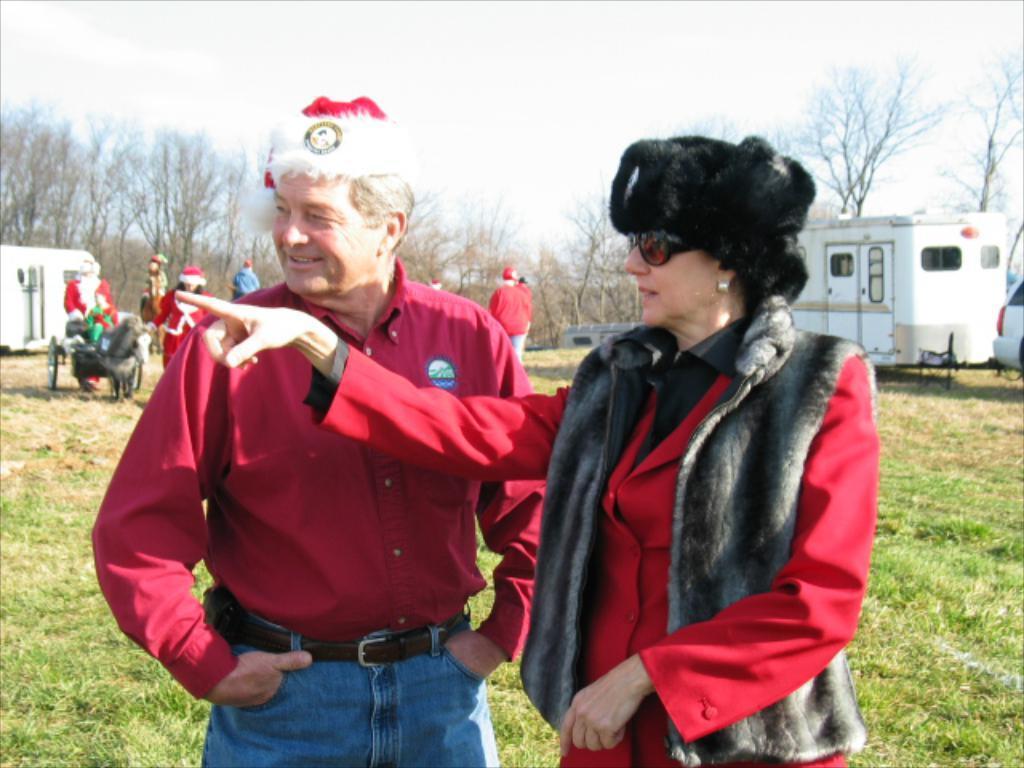How would you summarize this image in a sentence or two? In this image I can see group of people. In front the person is wearing red and black color dress. In the background I can see few vehicles, few dried trees and the sky is in white color. 